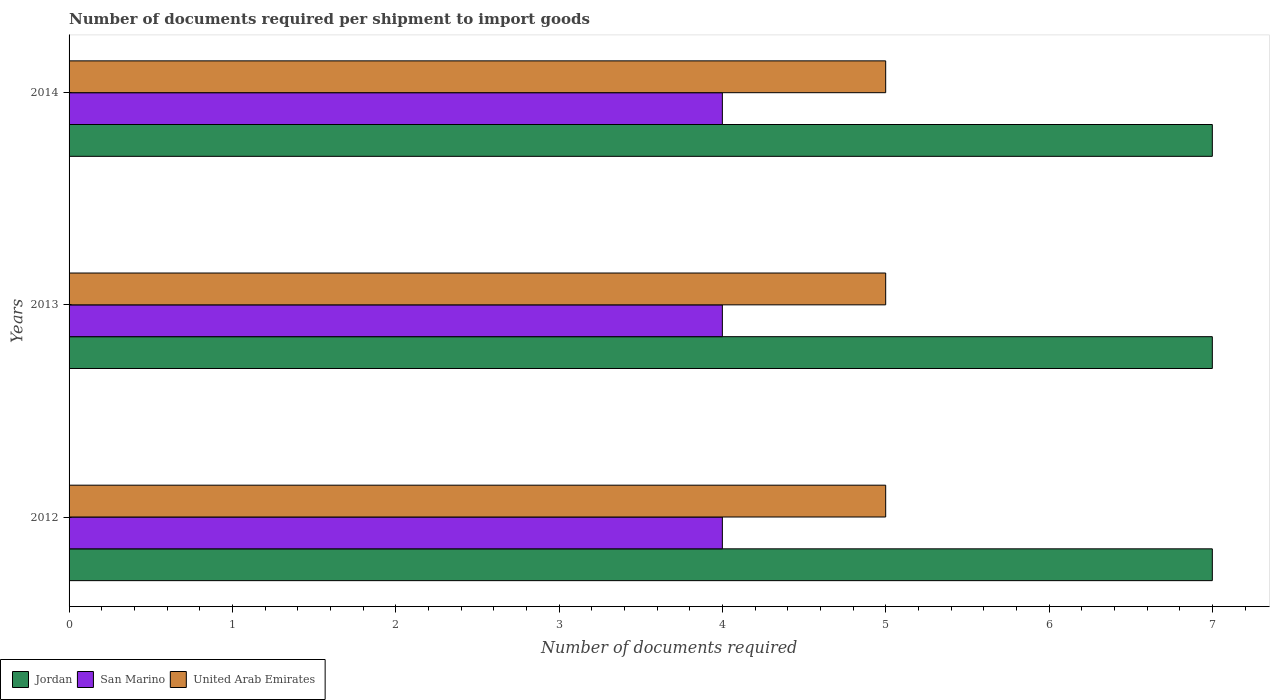How many different coloured bars are there?
Offer a very short reply. 3. Are the number of bars on each tick of the Y-axis equal?
Your answer should be very brief. Yes. In how many cases, is the number of bars for a given year not equal to the number of legend labels?
Offer a very short reply. 0. What is the number of documents required per shipment to import goods in San Marino in 2014?
Make the answer very short. 4. Across all years, what is the maximum number of documents required per shipment to import goods in United Arab Emirates?
Your answer should be compact. 5. Across all years, what is the minimum number of documents required per shipment to import goods in United Arab Emirates?
Make the answer very short. 5. What is the total number of documents required per shipment to import goods in San Marino in the graph?
Offer a very short reply. 12. What is the difference between the number of documents required per shipment to import goods in United Arab Emirates in 2013 and the number of documents required per shipment to import goods in San Marino in 2012?
Offer a terse response. 1. What is the average number of documents required per shipment to import goods in San Marino per year?
Provide a succinct answer. 4. In the year 2012, what is the difference between the number of documents required per shipment to import goods in United Arab Emirates and number of documents required per shipment to import goods in Jordan?
Offer a very short reply. -2. In how many years, is the number of documents required per shipment to import goods in United Arab Emirates greater than 0.4 ?
Ensure brevity in your answer.  3. Is the number of documents required per shipment to import goods in United Arab Emirates in 2012 less than that in 2013?
Your answer should be very brief. No. What is the difference between the highest and the second highest number of documents required per shipment to import goods in United Arab Emirates?
Ensure brevity in your answer.  0. In how many years, is the number of documents required per shipment to import goods in United Arab Emirates greater than the average number of documents required per shipment to import goods in United Arab Emirates taken over all years?
Ensure brevity in your answer.  0. Is the sum of the number of documents required per shipment to import goods in San Marino in 2013 and 2014 greater than the maximum number of documents required per shipment to import goods in Jordan across all years?
Your answer should be very brief. Yes. What does the 2nd bar from the top in 2014 represents?
Your answer should be very brief. San Marino. What does the 3rd bar from the bottom in 2012 represents?
Offer a very short reply. United Arab Emirates. How many bars are there?
Your response must be concise. 9. How many years are there in the graph?
Offer a very short reply. 3. Are the values on the major ticks of X-axis written in scientific E-notation?
Provide a short and direct response. No. Does the graph contain any zero values?
Ensure brevity in your answer.  No. Does the graph contain grids?
Your answer should be compact. No. How many legend labels are there?
Your answer should be compact. 3. What is the title of the graph?
Offer a terse response. Number of documents required per shipment to import goods. What is the label or title of the X-axis?
Ensure brevity in your answer.  Number of documents required. What is the label or title of the Y-axis?
Give a very brief answer. Years. What is the Number of documents required in Jordan in 2012?
Offer a terse response. 7. What is the Number of documents required in San Marino in 2012?
Keep it short and to the point. 4. What is the Number of documents required of Jordan in 2013?
Provide a short and direct response. 7. What is the Number of documents required in San Marino in 2013?
Provide a succinct answer. 4. What is the Number of documents required in United Arab Emirates in 2014?
Make the answer very short. 5. Across all years, what is the maximum Number of documents required in Jordan?
Offer a very short reply. 7. Across all years, what is the maximum Number of documents required in San Marino?
Your answer should be compact. 4. Across all years, what is the maximum Number of documents required of United Arab Emirates?
Provide a short and direct response. 5. Across all years, what is the minimum Number of documents required in San Marino?
Keep it short and to the point. 4. What is the total Number of documents required in San Marino in the graph?
Give a very brief answer. 12. What is the total Number of documents required of United Arab Emirates in the graph?
Your response must be concise. 15. What is the difference between the Number of documents required of San Marino in 2012 and that in 2013?
Make the answer very short. 0. What is the difference between the Number of documents required in San Marino in 2012 and that in 2014?
Your answer should be compact. 0. What is the difference between the Number of documents required in San Marino in 2013 and that in 2014?
Keep it short and to the point. 0. What is the difference between the Number of documents required in Jordan in 2012 and the Number of documents required in San Marino in 2013?
Provide a short and direct response. 3. What is the difference between the Number of documents required of Jordan in 2012 and the Number of documents required of United Arab Emirates in 2013?
Your response must be concise. 2. What is the difference between the Number of documents required in San Marino in 2012 and the Number of documents required in United Arab Emirates in 2013?
Make the answer very short. -1. What is the difference between the Number of documents required of San Marino in 2012 and the Number of documents required of United Arab Emirates in 2014?
Offer a very short reply. -1. What is the difference between the Number of documents required of Jordan in 2013 and the Number of documents required of San Marino in 2014?
Offer a terse response. 3. What is the average Number of documents required in Jordan per year?
Make the answer very short. 7. What is the average Number of documents required of United Arab Emirates per year?
Keep it short and to the point. 5. In the year 2012, what is the difference between the Number of documents required of Jordan and Number of documents required of San Marino?
Ensure brevity in your answer.  3. In the year 2012, what is the difference between the Number of documents required in Jordan and Number of documents required in United Arab Emirates?
Offer a terse response. 2. In the year 2013, what is the difference between the Number of documents required of Jordan and Number of documents required of San Marino?
Your answer should be very brief. 3. In the year 2013, what is the difference between the Number of documents required of Jordan and Number of documents required of United Arab Emirates?
Offer a terse response. 2. In the year 2014, what is the difference between the Number of documents required in Jordan and Number of documents required in San Marino?
Make the answer very short. 3. In the year 2014, what is the difference between the Number of documents required of Jordan and Number of documents required of United Arab Emirates?
Provide a succinct answer. 2. In the year 2014, what is the difference between the Number of documents required in San Marino and Number of documents required in United Arab Emirates?
Provide a short and direct response. -1. What is the ratio of the Number of documents required of San Marino in 2012 to that in 2013?
Offer a very short reply. 1. What is the ratio of the Number of documents required in United Arab Emirates in 2012 to that in 2013?
Your answer should be compact. 1. What is the ratio of the Number of documents required in Jordan in 2012 to that in 2014?
Provide a succinct answer. 1. What is the ratio of the Number of documents required of United Arab Emirates in 2012 to that in 2014?
Provide a short and direct response. 1. What is the ratio of the Number of documents required in Jordan in 2013 to that in 2014?
Give a very brief answer. 1. What is the ratio of the Number of documents required in San Marino in 2013 to that in 2014?
Offer a terse response. 1. What is the ratio of the Number of documents required of United Arab Emirates in 2013 to that in 2014?
Give a very brief answer. 1. What is the difference between the highest and the lowest Number of documents required in San Marino?
Provide a succinct answer. 0. What is the difference between the highest and the lowest Number of documents required of United Arab Emirates?
Provide a short and direct response. 0. 